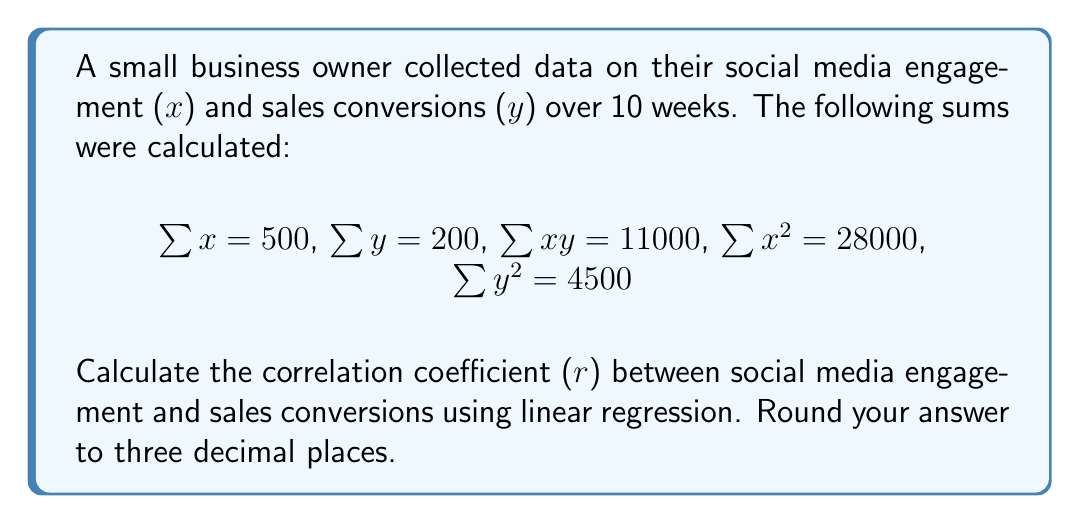What is the answer to this math problem? To calculate the correlation coefficient (r), we'll use the following formula:

$$r = \frac{n\sum xy - \sum x \sum y}{\sqrt{[n\sum x^2 - (\sum x)^2][n\sum y^2 - (\sum y)^2]}}$$

Where n is the number of data points (10 in this case).

Step 1: Calculate $n\sum xy$
$n\sum xy = 10 \times 11000 = 110000$

Step 2: Calculate $\sum x \sum y$
$\sum x \sum y = 500 \times 200 = 100000$

Step 3: Calculate $n\sum x^2$
$n\sum x^2 = 10 \times 28000 = 280000$

Step 4: Calculate $(\sum x)^2$
$(\sum x)^2 = 500^2 = 250000$

Step 5: Calculate $n\sum y^2$
$n\sum y^2 = 10 \times 4500 = 45000$

Step 6: Calculate $(\sum y)^2$
$(\sum y)^2 = 200^2 = 40000$

Step 7: Substitute values into the correlation coefficient formula
$$r = \frac{110000 - 100000}{\sqrt{[280000 - 250000][45000 - 40000]}}$$

Step 8: Simplify
$$r = \frac{10000}{\sqrt{30000 \times 5000}} = \frac{10000}{\sqrt{150000000}}$$

Step 9: Calculate the final result
$$r = \frac{10000}{12247.45} \approx 0.816$$

Rounding to three decimal places, we get 0.816.
Answer: 0.816 